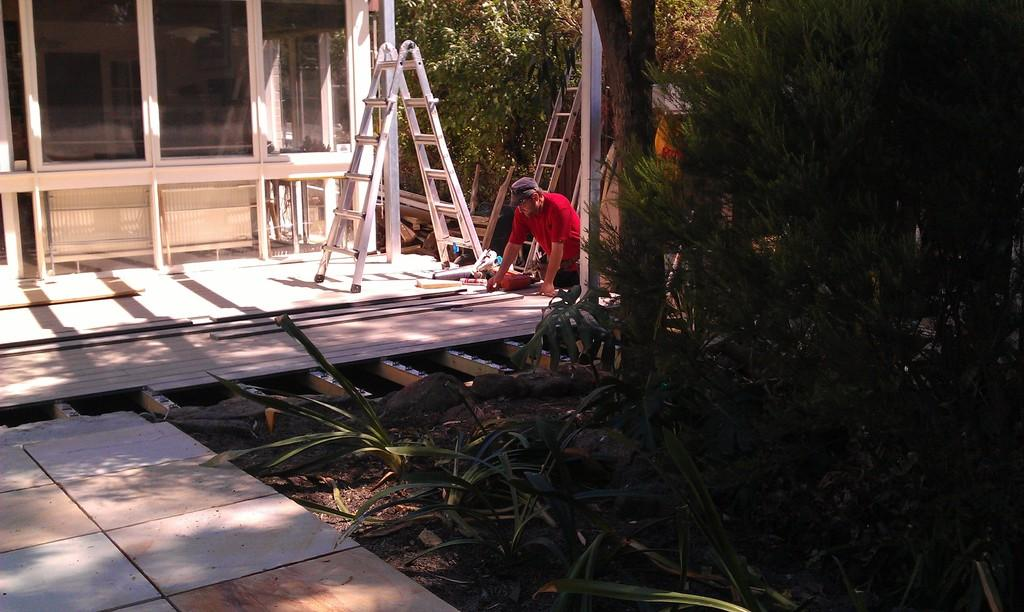What type of structure is visible in the image? There is a building with windows in the image. What materials are used for the objects in the image? There are wooden pieces in the image. Can you describe the person in the image? There is a person wearing a cap in the image. What tools are present in the image? There are ladders in the image. What type of vegetation is visible in the image? There are plants and trees in the image. What scientific discovery is being celebrated in the image? There is no indication of a scientific discovery or celebration in the image. 